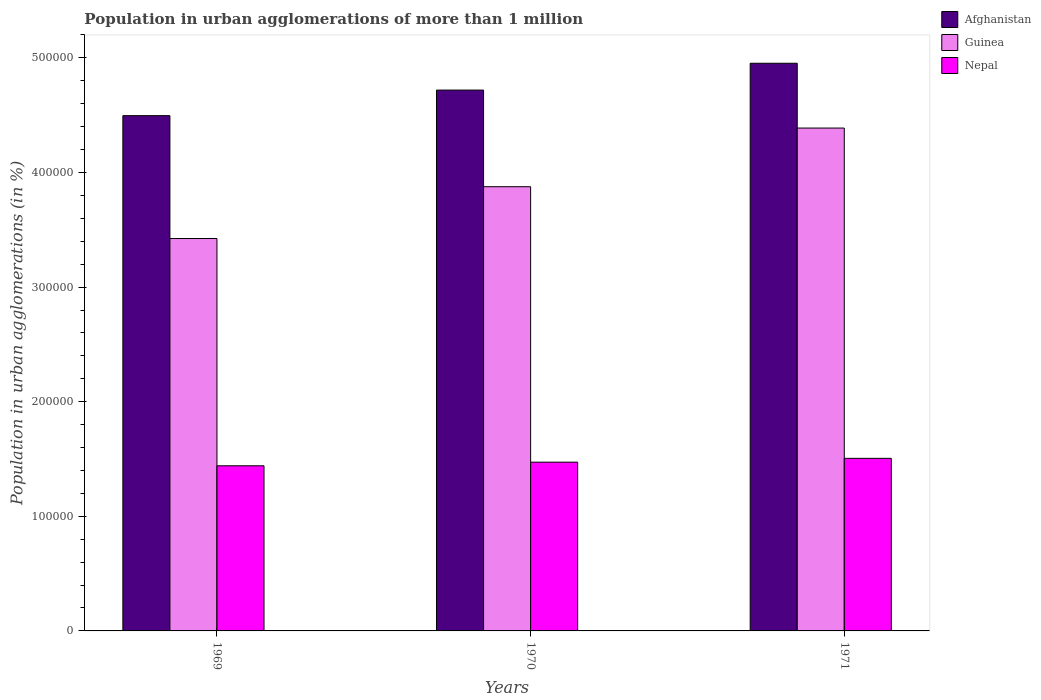How many different coloured bars are there?
Offer a terse response. 3. How many groups of bars are there?
Your answer should be compact. 3. Are the number of bars per tick equal to the number of legend labels?
Make the answer very short. Yes. How many bars are there on the 2nd tick from the left?
Keep it short and to the point. 3. In how many cases, is the number of bars for a given year not equal to the number of legend labels?
Keep it short and to the point. 0. What is the population in urban agglomerations in Afghanistan in 1969?
Provide a succinct answer. 4.50e+05. Across all years, what is the maximum population in urban agglomerations in Guinea?
Make the answer very short. 4.39e+05. Across all years, what is the minimum population in urban agglomerations in Afghanistan?
Your answer should be compact. 4.50e+05. In which year was the population in urban agglomerations in Nepal minimum?
Offer a very short reply. 1969. What is the total population in urban agglomerations in Guinea in the graph?
Keep it short and to the point. 1.17e+06. What is the difference between the population in urban agglomerations in Nepal in 1969 and that in 1970?
Provide a short and direct response. -3166. What is the difference between the population in urban agglomerations in Afghanistan in 1969 and the population in urban agglomerations in Guinea in 1971?
Your response must be concise. 1.08e+04. What is the average population in urban agglomerations in Guinea per year?
Provide a succinct answer. 3.90e+05. In the year 1971, what is the difference between the population in urban agglomerations in Afghanistan and population in urban agglomerations in Guinea?
Give a very brief answer. 5.65e+04. In how many years, is the population in urban agglomerations in Nepal greater than 360000 %?
Provide a succinct answer. 0. What is the ratio of the population in urban agglomerations in Nepal in 1969 to that in 1970?
Ensure brevity in your answer.  0.98. Is the difference between the population in urban agglomerations in Afghanistan in 1969 and 1970 greater than the difference between the population in urban agglomerations in Guinea in 1969 and 1970?
Give a very brief answer. Yes. What is the difference between the highest and the second highest population in urban agglomerations in Afghanistan?
Your answer should be compact. 2.34e+04. What is the difference between the highest and the lowest population in urban agglomerations in Afghanistan?
Ensure brevity in your answer.  4.57e+04. Is the sum of the population in urban agglomerations in Guinea in 1969 and 1970 greater than the maximum population in urban agglomerations in Afghanistan across all years?
Provide a succinct answer. Yes. What does the 2nd bar from the left in 1971 represents?
Your answer should be compact. Guinea. What does the 2nd bar from the right in 1971 represents?
Your response must be concise. Guinea. How many bars are there?
Offer a terse response. 9. Are all the bars in the graph horizontal?
Ensure brevity in your answer.  No. How many years are there in the graph?
Ensure brevity in your answer.  3. What is the difference between two consecutive major ticks on the Y-axis?
Keep it short and to the point. 1.00e+05. Does the graph contain any zero values?
Give a very brief answer. No. What is the title of the graph?
Your response must be concise. Population in urban agglomerations of more than 1 million. Does "New Caledonia" appear as one of the legend labels in the graph?
Provide a succinct answer. No. What is the label or title of the X-axis?
Keep it short and to the point. Years. What is the label or title of the Y-axis?
Provide a short and direct response. Population in urban agglomerations (in %). What is the Population in urban agglomerations (in %) in Afghanistan in 1969?
Keep it short and to the point. 4.50e+05. What is the Population in urban agglomerations (in %) of Guinea in 1969?
Keep it short and to the point. 3.42e+05. What is the Population in urban agglomerations (in %) in Nepal in 1969?
Provide a succinct answer. 1.44e+05. What is the Population in urban agglomerations (in %) in Afghanistan in 1970?
Ensure brevity in your answer.  4.72e+05. What is the Population in urban agglomerations (in %) of Guinea in 1970?
Give a very brief answer. 3.88e+05. What is the Population in urban agglomerations (in %) in Nepal in 1970?
Ensure brevity in your answer.  1.47e+05. What is the Population in urban agglomerations (in %) in Afghanistan in 1971?
Make the answer very short. 4.95e+05. What is the Population in urban agglomerations (in %) in Guinea in 1971?
Offer a terse response. 4.39e+05. What is the Population in urban agglomerations (in %) of Nepal in 1971?
Offer a very short reply. 1.51e+05. Across all years, what is the maximum Population in urban agglomerations (in %) of Afghanistan?
Make the answer very short. 4.95e+05. Across all years, what is the maximum Population in urban agglomerations (in %) of Guinea?
Your answer should be very brief. 4.39e+05. Across all years, what is the maximum Population in urban agglomerations (in %) of Nepal?
Provide a short and direct response. 1.51e+05. Across all years, what is the minimum Population in urban agglomerations (in %) of Afghanistan?
Offer a very short reply. 4.50e+05. Across all years, what is the minimum Population in urban agglomerations (in %) of Guinea?
Offer a very short reply. 3.42e+05. Across all years, what is the minimum Population in urban agglomerations (in %) of Nepal?
Offer a terse response. 1.44e+05. What is the total Population in urban agglomerations (in %) of Afghanistan in the graph?
Provide a short and direct response. 1.42e+06. What is the total Population in urban agglomerations (in %) of Guinea in the graph?
Offer a very short reply. 1.17e+06. What is the total Population in urban agglomerations (in %) in Nepal in the graph?
Ensure brevity in your answer.  4.42e+05. What is the difference between the Population in urban agglomerations (in %) in Afghanistan in 1969 and that in 1970?
Provide a short and direct response. -2.23e+04. What is the difference between the Population in urban agglomerations (in %) of Guinea in 1969 and that in 1970?
Ensure brevity in your answer.  -4.52e+04. What is the difference between the Population in urban agglomerations (in %) of Nepal in 1969 and that in 1970?
Provide a short and direct response. -3166. What is the difference between the Population in urban agglomerations (in %) in Afghanistan in 1969 and that in 1971?
Ensure brevity in your answer.  -4.57e+04. What is the difference between the Population in urban agglomerations (in %) in Guinea in 1969 and that in 1971?
Ensure brevity in your answer.  -9.64e+04. What is the difference between the Population in urban agglomerations (in %) of Nepal in 1969 and that in 1971?
Ensure brevity in your answer.  -6487. What is the difference between the Population in urban agglomerations (in %) in Afghanistan in 1970 and that in 1971?
Offer a very short reply. -2.34e+04. What is the difference between the Population in urban agglomerations (in %) of Guinea in 1970 and that in 1971?
Provide a short and direct response. -5.12e+04. What is the difference between the Population in urban agglomerations (in %) in Nepal in 1970 and that in 1971?
Make the answer very short. -3321. What is the difference between the Population in urban agglomerations (in %) of Afghanistan in 1969 and the Population in urban agglomerations (in %) of Guinea in 1970?
Offer a terse response. 6.20e+04. What is the difference between the Population in urban agglomerations (in %) of Afghanistan in 1969 and the Population in urban agglomerations (in %) of Nepal in 1970?
Offer a very short reply. 3.02e+05. What is the difference between the Population in urban agglomerations (in %) in Guinea in 1969 and the Population in urban agglomerations (in %) in Nepal in 1970?
Your answer should be very brief. 1.95e+05. What is the difference between the Population in urban agglomerations (in %) in Afghanistan in 1969 and the Population in urban agglomerations (in %) in Guinea in 1971?
Ensure brevity in your answer.  1.08e+04. What is the difference between the Population in urban agglomerations (in %) of Afghanistan in 1969 and the Population in urban agglomerations (in %) of Nepal in 1971?
Provide a succinct answer. 2.99e+05. What is the difference between the Population in urban agglomerations (in %) in Guinea in 1969 and the Population in urban agglomerations (in %) in Nepal in 1971?
Make the answer very short. 1.92e+05. What is the difference between the Population in urban agglomerations (in %) in Afghanistan in 1970 and the Population in urban agglomerations (in %) in Guinea in 1971?
Your answer should be compact. 3.31e+04. What is the difference between the Population in urban agglomerations (in %) of Afghanistan in 1970 and the Population in urban agglomerations (in %) of Nepal in 1971?
Offer a terse response. 3.21e+05. What is the difference between the Population in urban agglomerations (in %) of Guinea in 1970 and the Population in urban agglomerations (in %) of Nepal in 1971?
Give a very brief answer. 2.37e+05. What is the average Population in urban agglomerations (in %) of Afghanistan per year?
Ensure brevity in your answer.  4.72e+05. What is the average Population in urban agglomerations (in %) of Guinea per year?
Your answer should be very brief. 3.90e+05. What is the average Population in urban agglomerations (in %) of Nepal per year?
Your answer should be compact. 1.47e+05. In the year 1969, what is the difference between the Population in urban agglomerations (in %) of Afghanistan and Population in urban agglomerations (in %) of Guinea?
Provide a short and direct response. 1.07e+05. In the year 1969, what is the difference between the Population in urban agglomerations (in %) in Afghanistan and Population in urban agglomerations (in %) in Nepal?
Give a very brief answer. 3.06e+05. In the year 1969, what is the difference between the Population in urban agglomerations (in %) in Guinea and Population in urban agglomerations (in %) in Nepal?
Your answer should be very brief. 1.98e+05. In the year 1970, what is the difference between the Population in urban agglomerations (in %) of Afghanistan and Population in urban agglomerations (in %) of Guinea?
Provide a succinct answer. 8.43e+04. In the year 1970, what is the difference between the Population in urban agglomerations (in %) of Afghanistan and Population in urban agglomerations (in %) of Nepal?
Your answer should be very brief. 3.25e+05. In the year 1970, what is the difference between the Population in urban agglomerations (in %) of Guinea and Population in urban agglomerations (in %) of Nepal?
Your answer should be very brief. 2.40e+05. In the year 1971, what is the difference between the Population in urban agglomerations (in %) in Afghanistan and Population in urban agglomerations (in %) in Guinea?
Offer a very short reply. 5.65e+04. In the year 1971, what is the difference between the Population in urban agglomerations (in %) of Afghanistan and Population in urban agglomerations (in %) of Nepal?
Your answer should be very brief. 3.45e+05. In the year 1971, what is the difference between the Population in urban agglomerations (in %) of Guinea and Population in urban agglomerations (in %) of Nepal?
Offer a terse response. 2.88e+05. What is the ratio of the Population in urban agglomerations (in %) in Afghanistan in 1969 to that in 1970?
Make the answer very short. 0.95. What is the ratio of the Population in urban agglomerations (in %) of Guinea in 1969 to that in 1970?
Make the answer very short. 0.88. What is the ratio of the Population in urban agglomerations (in %) in Nepal in 1969 to that in 1970?
Provide a short and direct response. 0.98. What is the ratio of the Population in urban agglomerations (in %) in Afghanistan in 1969 to that in 1971?
Provide a succinct answer. 0.91. What is the ratio of the Population in urban agglomerations (in %) in Guinea in 1969 to that in 1971?
Your answer should be very brief. 0.78. What is the ratio of the Population in urban agglomerations (in %) of Nepal in 1969 to that in 1971?
Give a very brief answer. 0.96. What is the ratio of the Population in urban agglomerations (in %) of Afghanistan in 1970 to that in 1971?
Offer a very short reply. 0.95. What is the ratio of the Population in urban agglomerations (in %) of Guinea in 1970 to that in 1971?
Your answer should be compact. 0.88. What is the ratio of the Population in urban agglomerations (in %) in Nepal in 1970 to that in 1971?
Offer a terse response. 0.98. What is the difference between the highest and the second highest Population in urban agglomerations (in %) of Afghanistan?
Your answer should be very brief. 2.34e+04. What is the difference between the highest and the second highest Population in urban agglomerations (in %) in Guinea?
Your answer should be very brief. 5.12e+04. What is the difference between the highest and the second highest Population in urban agglomerations (in %) in Nepal?
Offer a very short reply. 3321. What is the difference between the highest and the lowest Population in urban agglomerations (in %) of Afghanistan?
Give a very brief answer. 4.57e+04. What is the difference between the highest and the lowest Population in urban agglomerations (in %) in Guinea?
Provide a short and direct response. 9.64e+04. What is the difference between the highest and the lowest Population in urban agglomerations (in %) of Nepal?
Provide a succinct answer. 6487. 